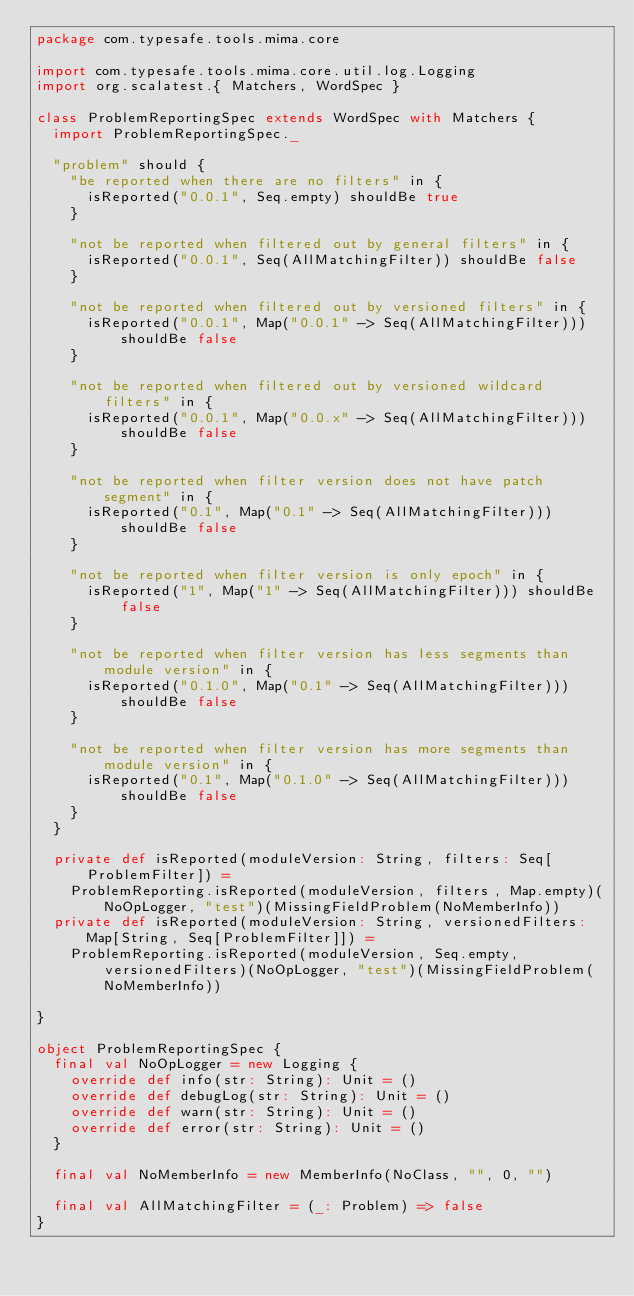<code> <loc_0><loc_0><loc_500><loc_500><_Scala_>package com.typesafe.tools.mima.core

import com.typesafe.tools.mima.core.util.log.Logging
import org.scalatest.{ Matchers, WordSpec }

class ProblemReportingSpec extends WordSpec with Matchers {
  import ProblemReportingSpec._

  "problem" should {
    "be reported when there are no filters" in {
      isReported("0.0.1", Seq.empty) shouldBe true
    }

    "not be reported when filtered out by general filters" in {
      isReported("0.0.1", Seq(AllMatchingFilter)) shouldBe false
    }

    "not be reported when filtered out by versioned filters" in {
      isReported("0.0.1", Map("0.0.1" -> Seq(AllMatchingFilter))) shouldBe false
    }

    "not be reported when filtered out by versioned wildcard filters" in {
      isReported("0.0.1", Map("0.0.x" -> Seq(AllMatchingFilter))) shouldBe false
    }

    "not be reported when filter version does not have patch segment" in {
      isReported("0.1", Map("0.1" -> Seq(AllMatchingFilter))) shouldBe false
    }

    "not be reported when filter version is only epoch" in {
      isReported("1", Map("1" -> Seq(AllMatchingFilter))) shouldBe false
    }

    "not be reported when filter version has less segments than module version" in {
      isReported("0.1.0", Map("0.1" -> Seq(AllMatchingFilter))) shouldBe false
    }

    "not be reported when filter version has more segments than module version" in {
      isReported("0.1", Map("0.1.0" -> Seq(AllMatchingFilter))) shouldBe false
    }
  }

  private def isReported(moduleVersion: String, filters: Seq[ProblemFilter]) =
    ProblemReporting.isReported(moduleVersion, filters, Map.empty)(NoOpLogger, "test")(MissingFieldProblem(NoMemberInfo))
  private def isReported(moduleVersion: String, versionedFilters: Map[String, Seq[ProblemFilter]]) =
    ProblemReporting.isReported(moduleVersion, Seq.empty, versionedFilters)(NoOpLogger, "test")(MissingFieldProblem(NoMemberInfo))

}

object ProblemReportingSpec {
  final val NoOpLogger = new Logging {
    override def info(str: String): Unit = ()
    override def debugLog(str: String): Unit = ()
    override def warn(str: String): Unit = ()
    override def error(str: String): Unit = ()
  }

  final val NoMemberInfo = new MemberInfo(NoClass, "", 0, "")

  final val AllMatchingFilter = (_: Problem) => false
}
</code> 